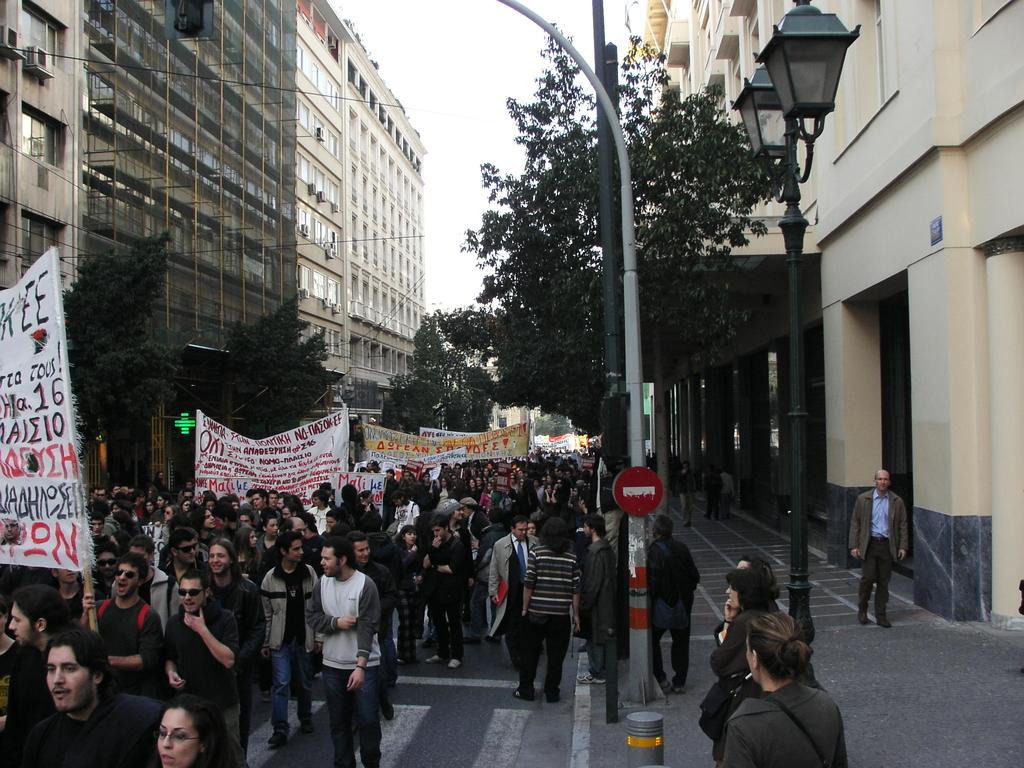Please provide a concise description of this image. In this image we can see many people are walking on the road among them few are holding banners in their hands. Here we can see poles, light poles, trees, buildings and the sky in the background. 